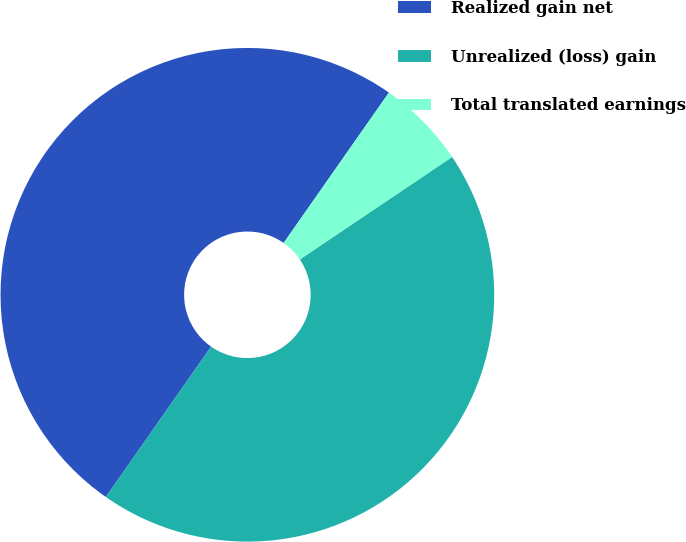Convert chart. <chart><loc_0><loc_0><loc_500><loc_500><pie_chart><fcel>Realized gain net<fcel>Unrealized (loss) gain<fcel>Total translated earnings<nl><fcel>50.0%<fcel>44.15%<fcel>5.85%<nl></chart> 